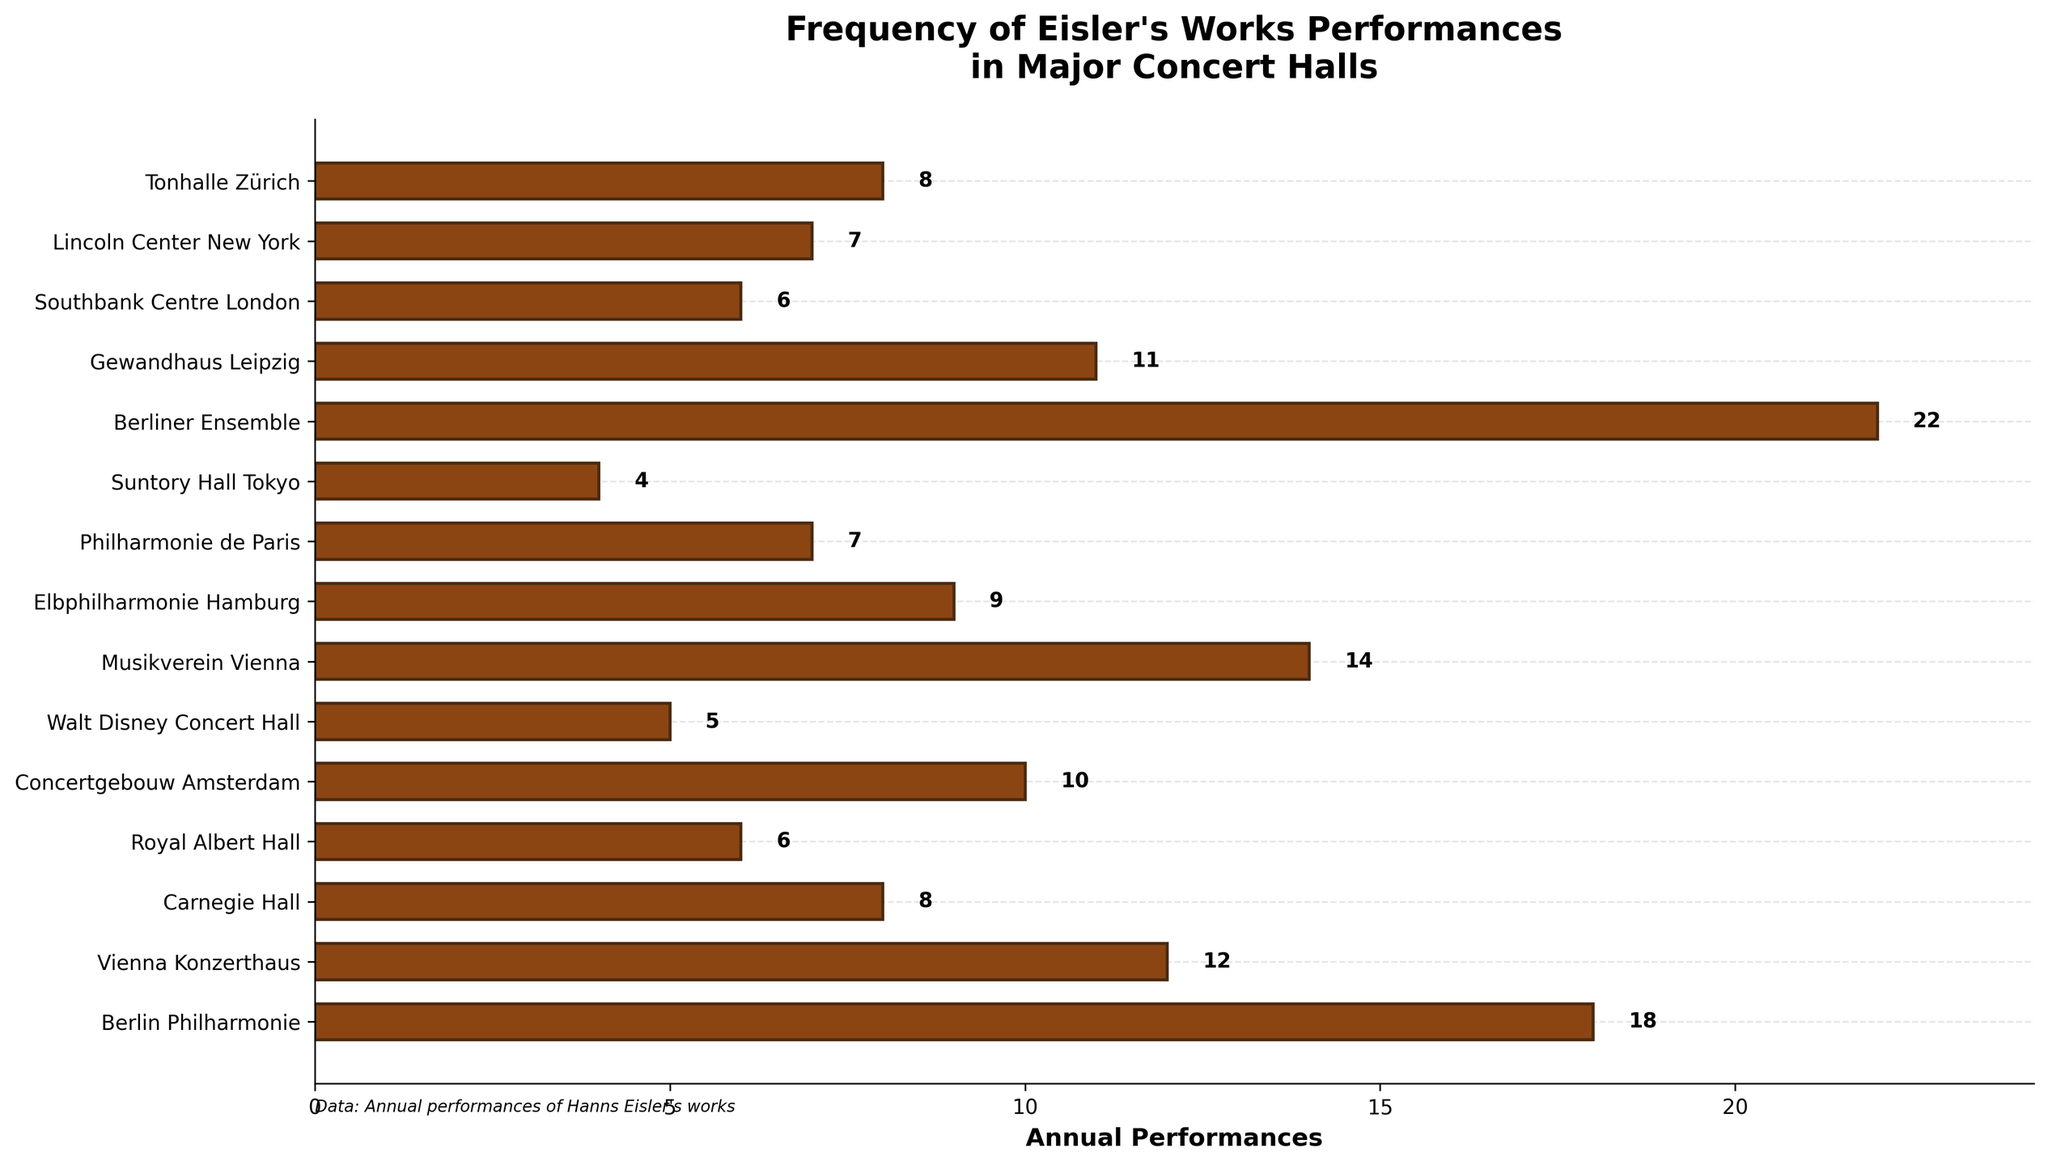Which concert hall has the highest number of annual performances of Eisler's works? To find the hall with the highest number, look for the longest bar in the chart. The longest bar corresponds to 'Berliner Ensemble' with 22 performances.
Answer: Berliner Ensemble Which concert hall has the fewest performances of Eisler's works annually? To find the hall with the fewest number, locate the shortest bar in the chart. The shortest bar corresponds to 'Suntory Hall Tokyo' with 4 performances.
Answer: Suntory Hall Tokyo How many performances of Eisler's works are held annually at the Lincoln Center New York? Locate the bar representing 'Lincoln Center New York' and read the value next to it. It corresponds to 7 performances.
Answer: 7 What is the difference in annual performances between Musikverein Vienna and Philharmonie de Paris? Find the values for both, which are 14 (Musikverein Vienna) and 7 (Philharmonie de Paris). Subtract the smaller from the larger: 14 - 7 = 7.
Answer: 7 Which concert halls have more than 10 annual performances of Eisler's works? Identify all bars longer than 10. These correspond to 'Berlin Philharmonie' (18), 'Vienna Konzerthaus' (12), 'Musikverein Vienna' (14), and 'Berliner Ensemble' (22).
Answer: Berlin Philharmonie, Vienna Konzerthaus, Musikverein Vienna, Berliner Ensemble How many more performances does Concertgebouw Amsterdam have compared to Royal Albert Hall? Find the values for both, which are 10 (Concertgebouw Amsterdam) and 6 (Royal Albert Hall). Subtract the smaller from the larger: 10 - 6 = 4.
Answer: 4 What is the total number of performances in both German concert halls (Berlin Philharmonie and Berliner Ensemble)? Add the performances of both: 18 (Berlin Philharmonie) + 22 (Berliner Ensemble) = 40.
Answer: 40 Which concert hall has annual performances closest to the median of all listed venues? Arrange the performance numbers in ascending order: 4, 5, 6, 6, 7, 7, 8, 8, 9, 10, 11, 12, 14, 18, 22. The median is the 8th value in this ordered list, which is 8. Both Carnegie Hall and Tonhalle Zürich have 8 performances.
Answer: Carnegie Hall, Tonhalle Zürich Compare the total annual performances of venues from Vienna and New York. Which city has more? Add the performances from Vienna: 12 (Vienna Konzerthaus) + 14 (Musikverein Vienna) = 26. Add from New York: 8 (Carnegie Hall) + 7 (Lincoln Center New York) = 15. Compare the totals: 26 (Vienna) > 15 (New York).
Answer: Vienna Among the listed concert halls, which specific color is used for the bar chart? All the bars in the chart are colored with a brownish hue represented by "#8B4513".
Answer: Brown 